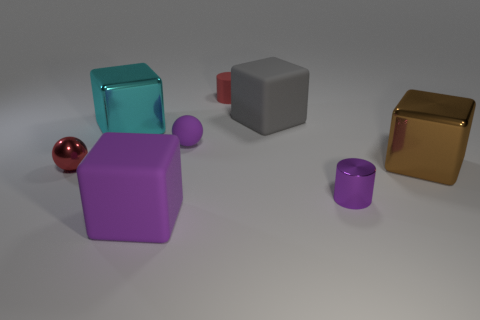Are there any other things of the same color as the small metallic ball?
Provide a succinct answer. Yes. The big thing that is both to the right of the cyan object and behind the brown thing has what shape?
Keep it short and to the point. Cube. Are there an equal number of tiny red things to the right of the gray block and rubber things that are on the right side of the tiny rubber cylinder?
Offer a very short reply. No. What number of blocks are big purple matte objects or big gray things?
Provide a succinct answer. 2. What number of purple objects have the same material as the small red cylinder?
Offer a terse response. 2. There is a matte object that is the same color as the matte ball; what is its shape?
Your answer should be compact. Cube. What is the material of the large cube that is both on the right side of the red matte object and to the left of the small shiny cylinder?
Your answer should be compact. Rubber. The tiny red thing on the left side of the red matte object has what shape?
Keep it short and to the point. Sphere. The metallic thing to the right of the cylinder that is in front of the small red sphere is what shape?
Make the answer very short. Cube. Is there a red shiny thing that has the same shape as the large gray matte object?
Make the answer very short. No. 